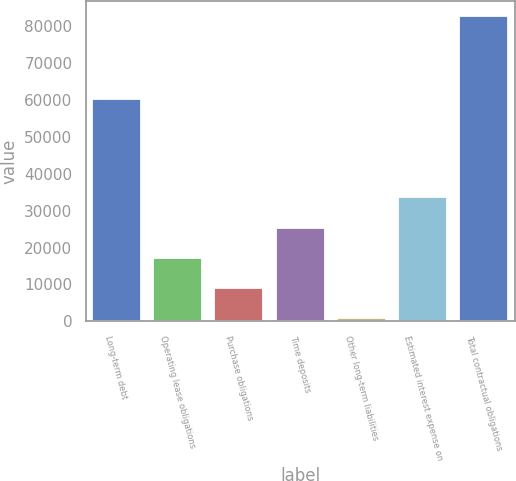Convert chart. <chart><loc_0><loc_0><loc_500><loc_500><bar_chart><fcel>Long-term debt<fcel>Operating lease obligations<fcel>Purchase obligations<fcel>Time deposits<fcel>Other long-term liabilities<fcel>Estimated interest expense on<fcel>Total contractual obligations<nl><fcel>60106<fcel>17200<fcel>9018.5<fcel>25381.5<fcel>837<fcel>33563<fcel>82652<nl></chart> 